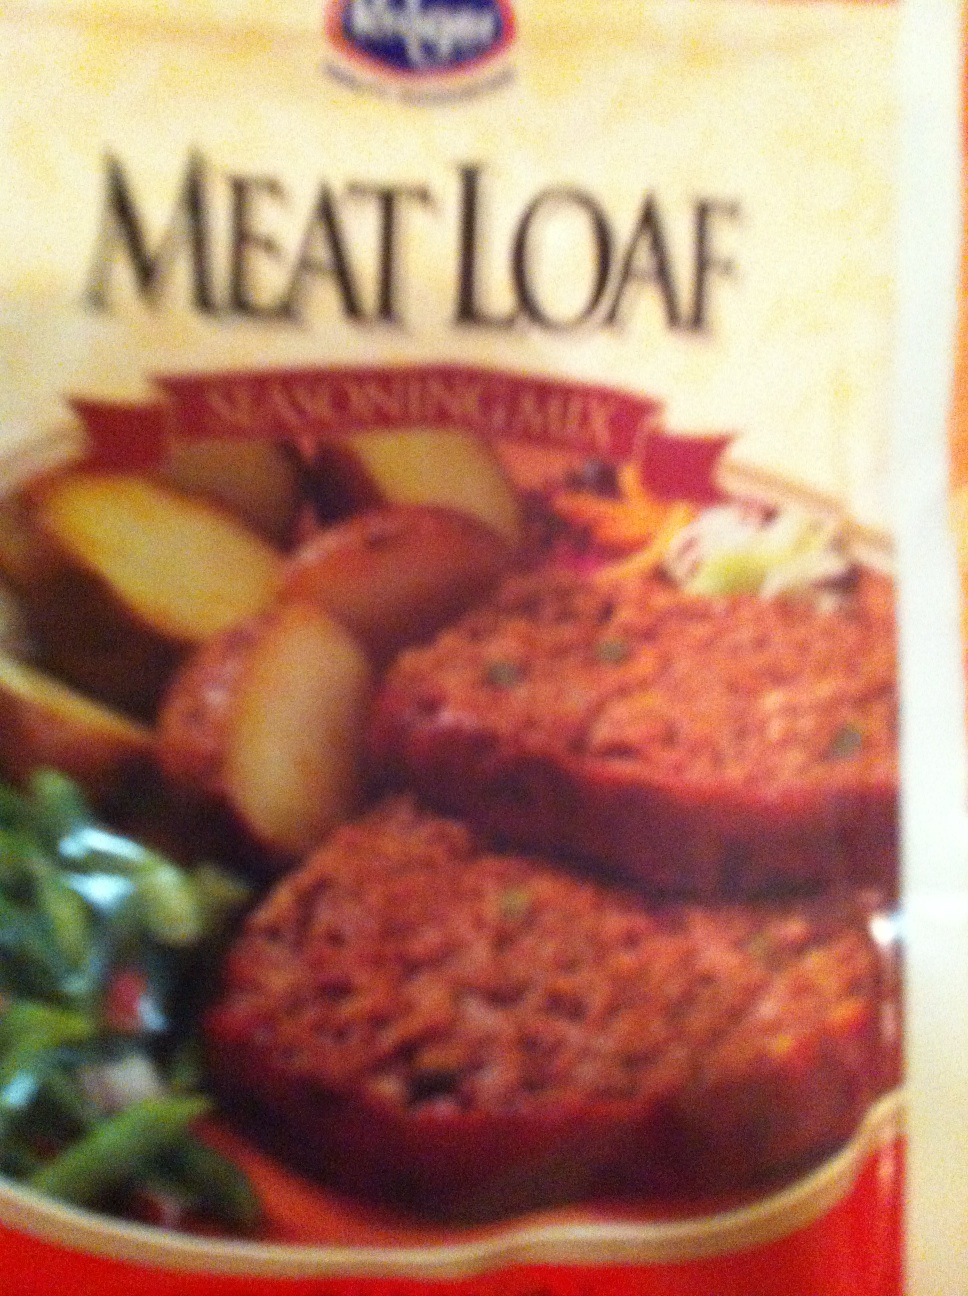Could you tell the contents of this package please? Thank you. Good Morning. from Vizwiz meat loaf 